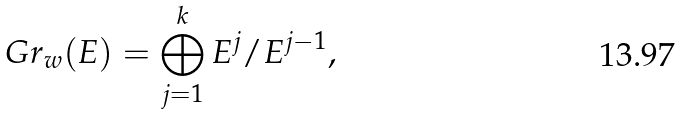Convert formula to latex. <formula><loc_0><loc_0><loc_500><loc_500>G r _ { w } ( E ) = \bigoplus _ { j = 1 } ^ { k } E ^ { j } / E ^ { j - 1 } ,</formula> 